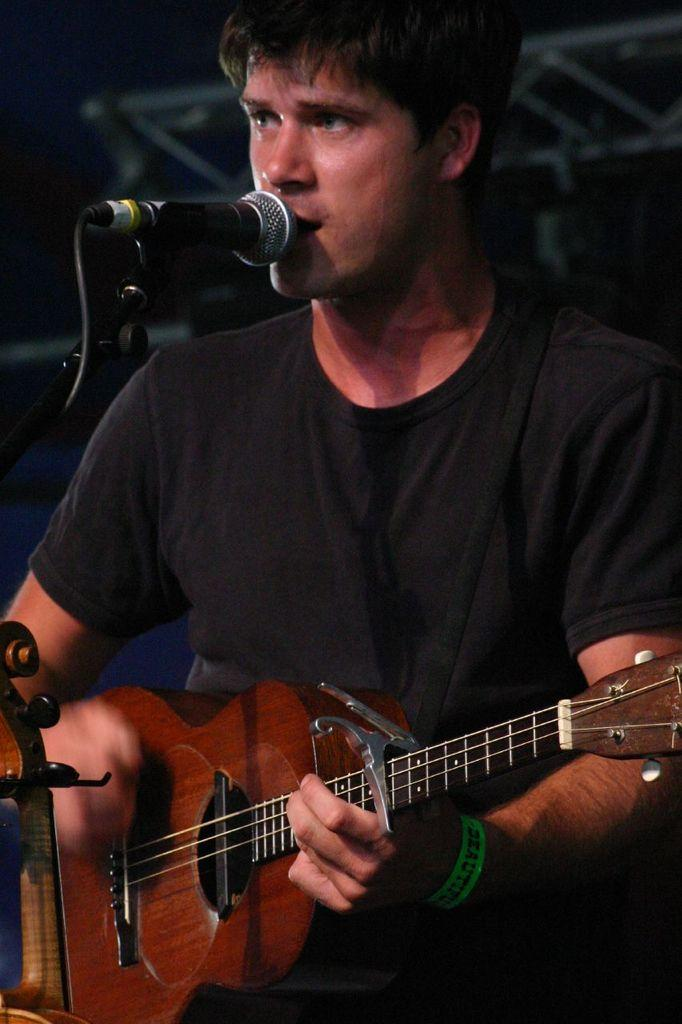What is the man in the image doing? The man is playing a guitar and singing. What object is the man using to amplify his voice? There is a microphone in the image. What time of day is it in the image, and is the mailbox full of mail? The provided facts do not mention the time of day or the presence of a mailbox, so we cannot determine if it is morning or if the mailbox is full of mail. 